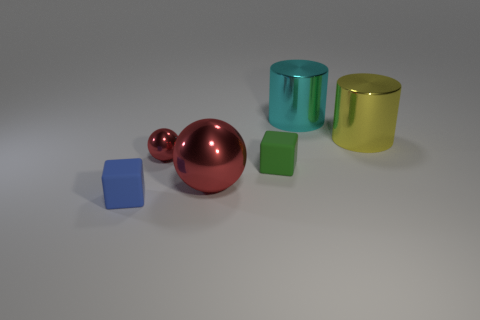Add 1 metal things. How many objects exist? 7 Subtract all balls. How many objects are left? 4 Add 6 small blue blocks. How many small blue blocks are left? 7 Add 3 cyan shiny objects. How many cyan shiny objects exist? 4 Subtract 1 cyan cylinders. How many objects are left? 5 Subtract all tiny red spheres. Subtract all tiny blue blocks. How many objects are left? 4 